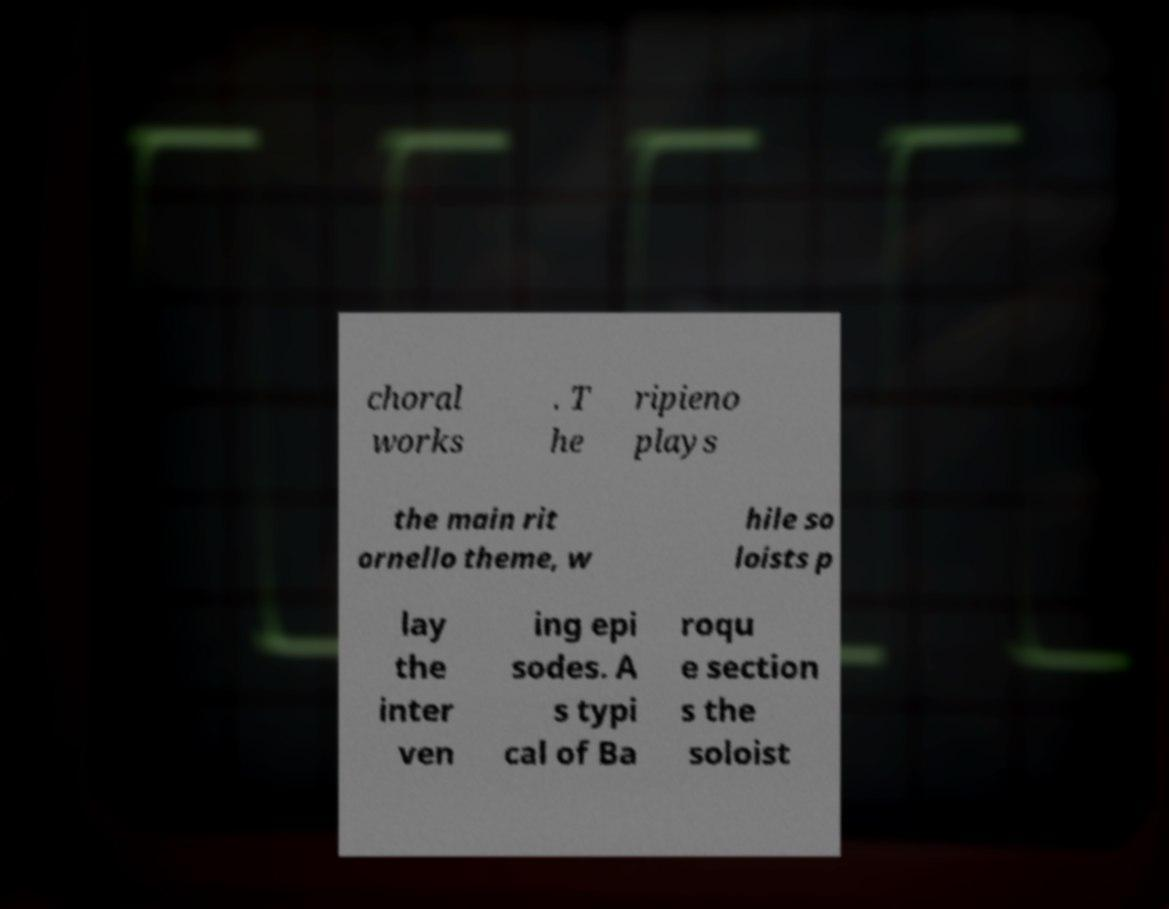Please read and relay the text visible in this image. What does it say? choral works . T he ripieno plays the main rit ornello theme, w hile so loists p lay the inter ven ing epi sodes. A s typi cal of Ba roqu e section s the soloist 